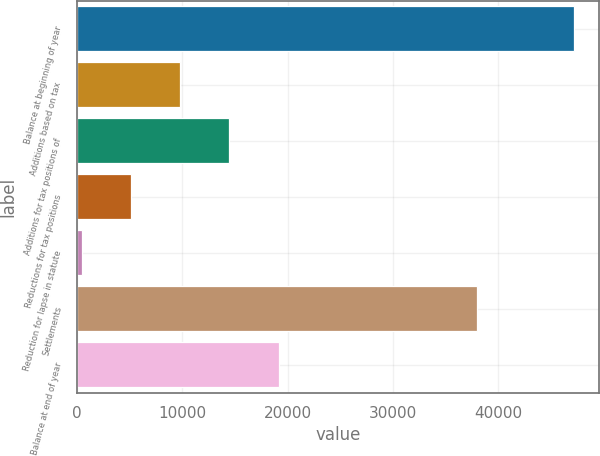Convert chart. <chart><loc_0><loc_0><loc_500><loc_500><bar_chart><fcel>Balance at beginning of year<fcel>Additions based on tax<fcel>Additions for tax positions of<fcel>Reductions for tax positions<fcel>Reduction for lapse in statute<fcel>Settlements<fcel>Balance at end of year<nl><fcel>47190<fcel>9822.8<fcel>14493.7<fcel>5151.9<fcel>481<fcel>37995<fcel>19164.6<nl></chart> 